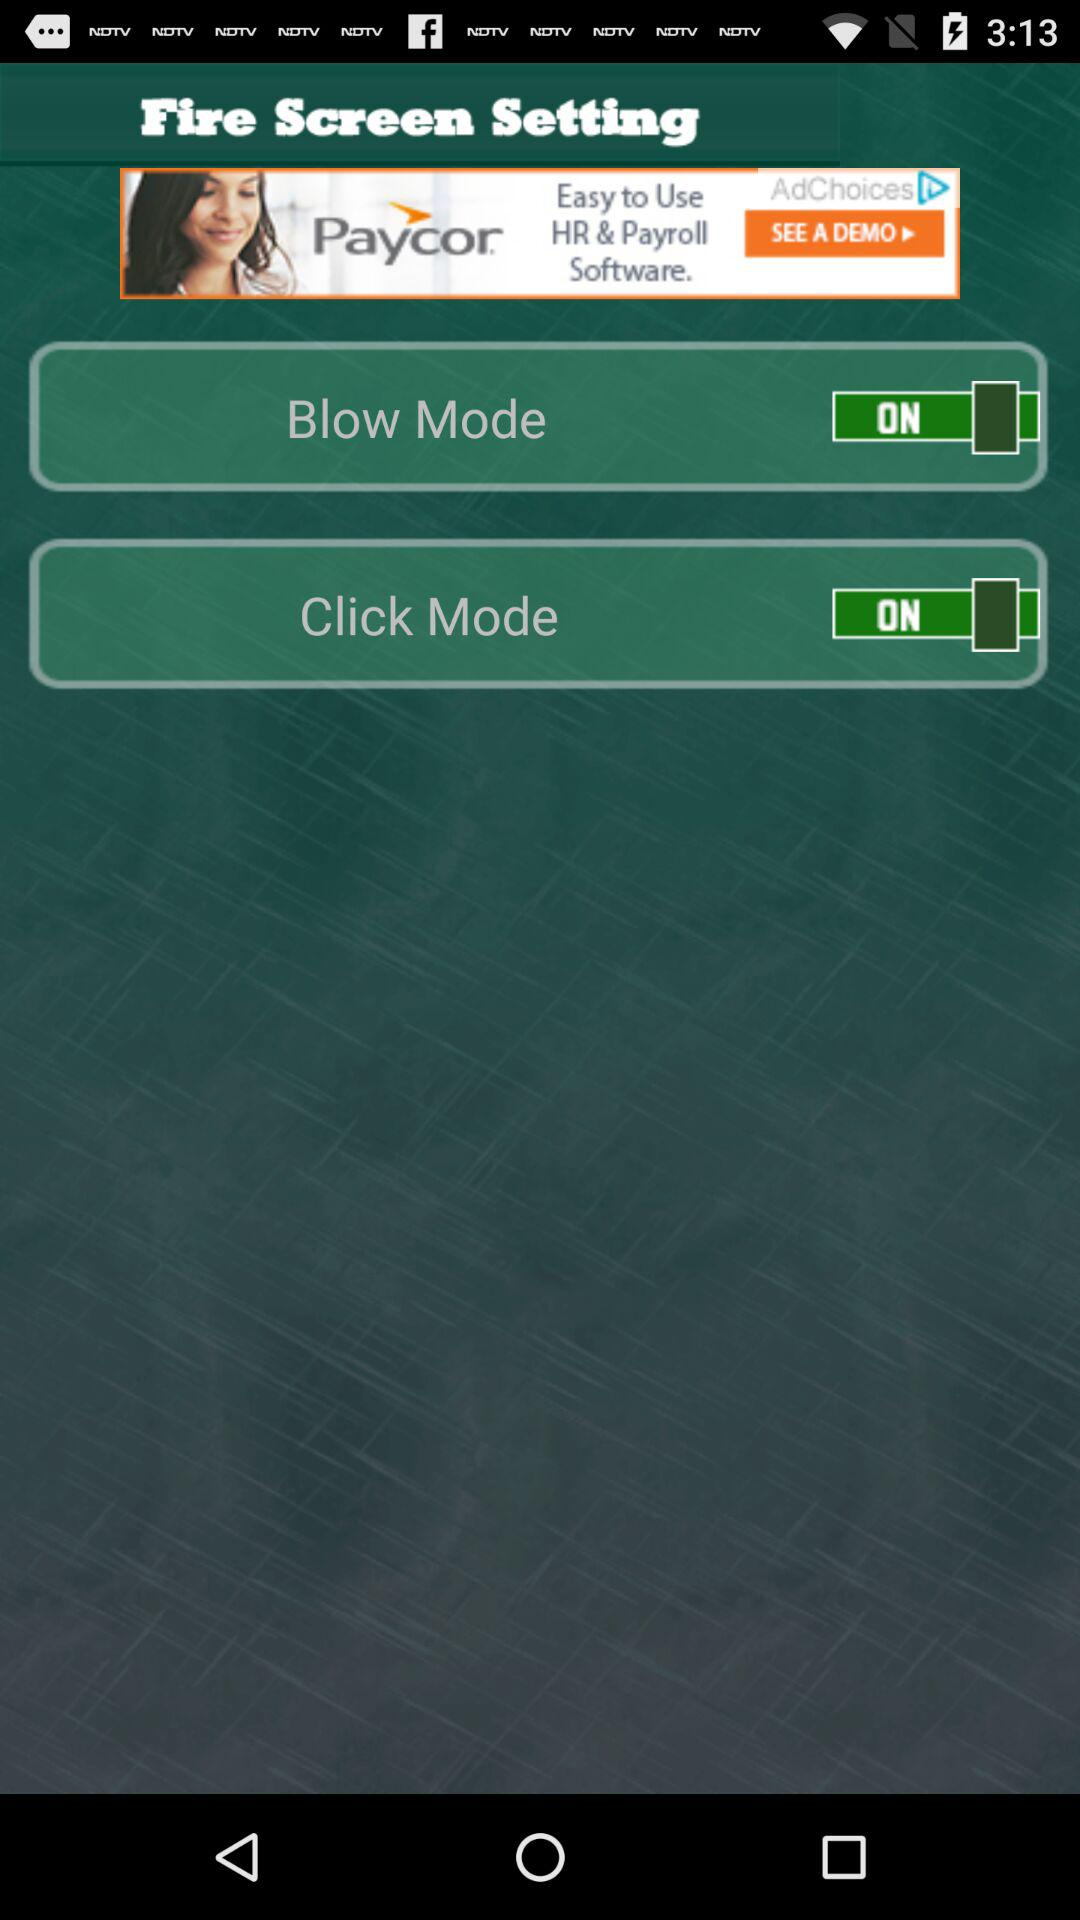What is the status of blow mode? The status is on. 